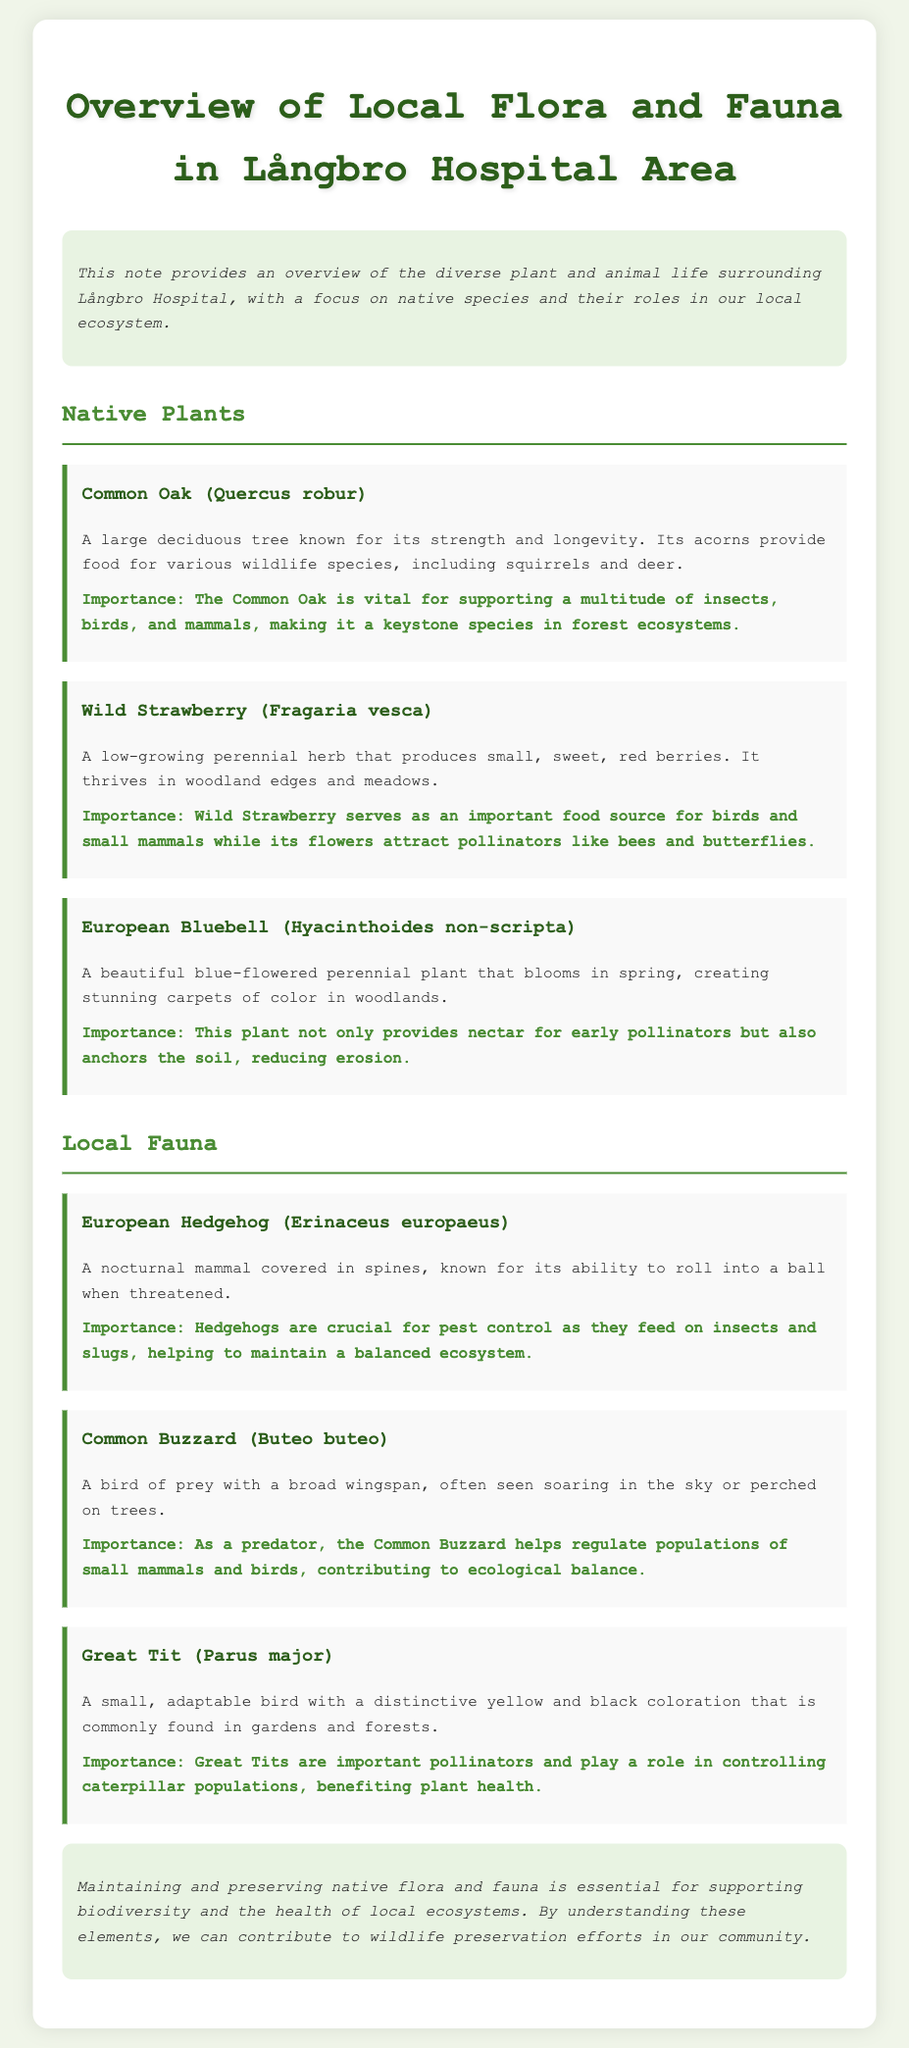what is the title of the document? The title can be found at the top of the document, stating the main subject of the content.
Answer: Overview of Local Flora and Fauna in Långbro Hospital Area what is the first native plant mentioned? The first native plant listed in the document is found under the Native Plants section.
Answer: Common Oak (Quercus robur) what does the Common Oak provide for wildlife? This information is detailed in the description of the Common Oak, highlighting its contribution to local wildlife.
Answer: Acorns how does the European Bluebell contribute to the ecosystem? The importance section of the European Bluebell describes its ecological role.
Answer: It provides nectar for early pollinators and anchors the soil which fauna is known for pest control? The function of pest control is described in the section about one of the local fauna.
Answer: European Hedgehog (Erinaceus europaeus) how many types of local fauna are mentioned? Counting the distinct fauna listed in the Local Fauna section gives the total number.
Answer: Three what color is the Great Tit? The description of the Great Tit includes information about its coloration.
Answer: Yellow and black why are native species important? The conclusion section summarizes the significance of preserving native species in the ecosystem.
Answer: For supporting biodiversity and the health of local ecosystems 